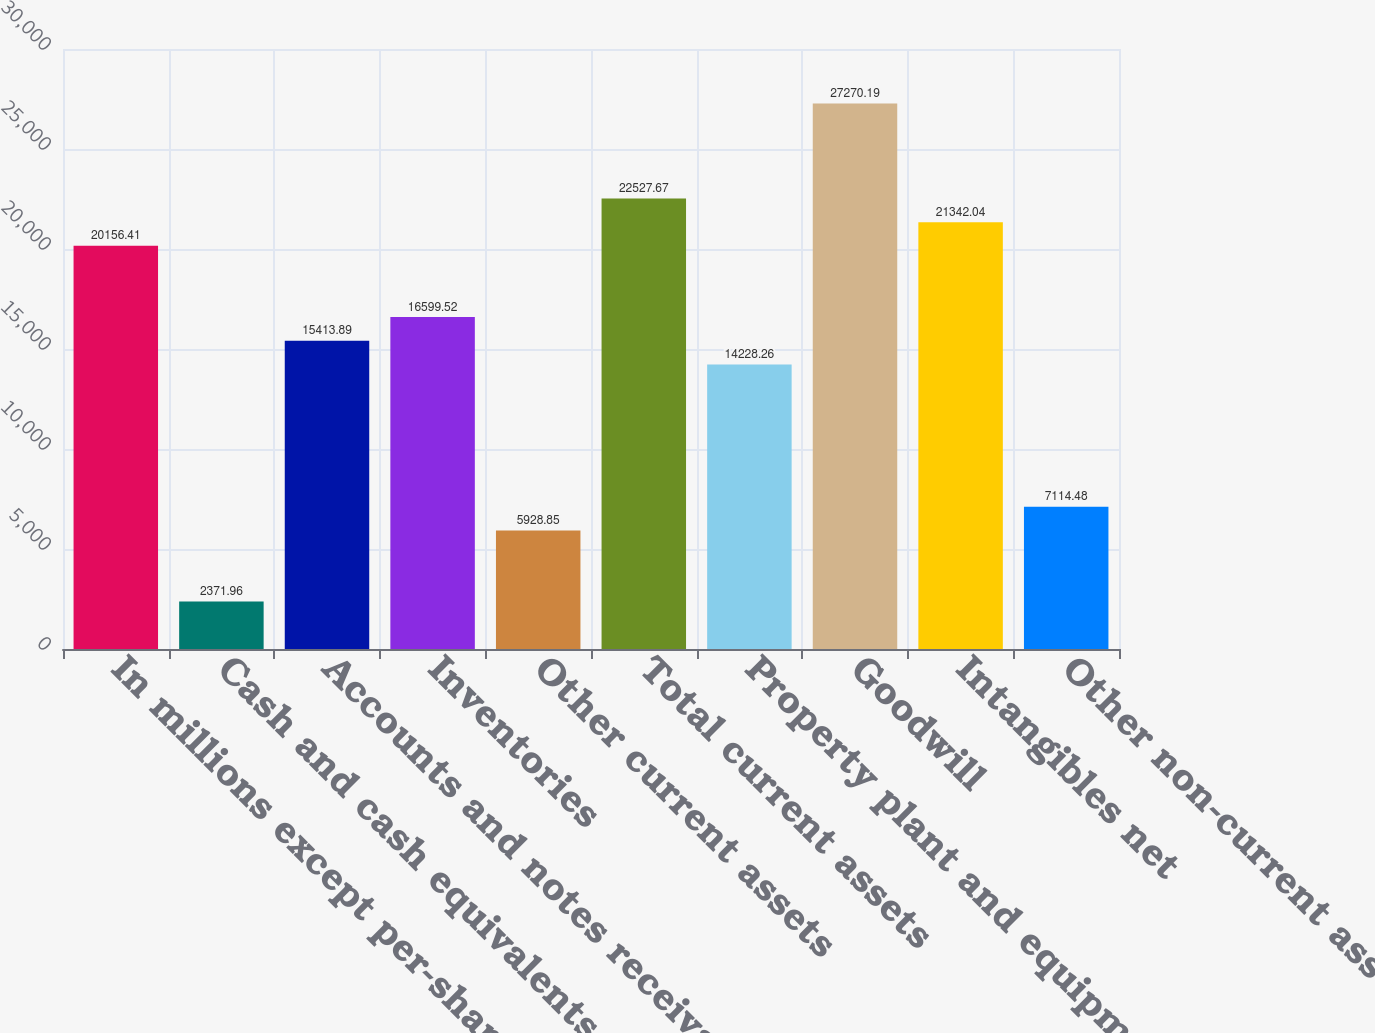<chart> <loc_0><loc_0><loc_500><loc_500><bar_chart><fcel>In millions except per-share<fcel>Cash and cash equivalents<fcel>Accounts and notes receivable<fcel>Inventories<fcel>Other current assets<fcel>Total current assets<fcel>Property plant and equipment<fcel>Goodwill<fcel>Intangibles net<fcel>Other non-current assets<nl><fcel>20156.4<fcel>2371.96<fcel>15413.9<fcel>16599.5<fcel>5928.85<fcel>22527.7<fcel>14228.3<fcel>27270.2<fcel>21342<fcel>7114.48<nl></chart> 